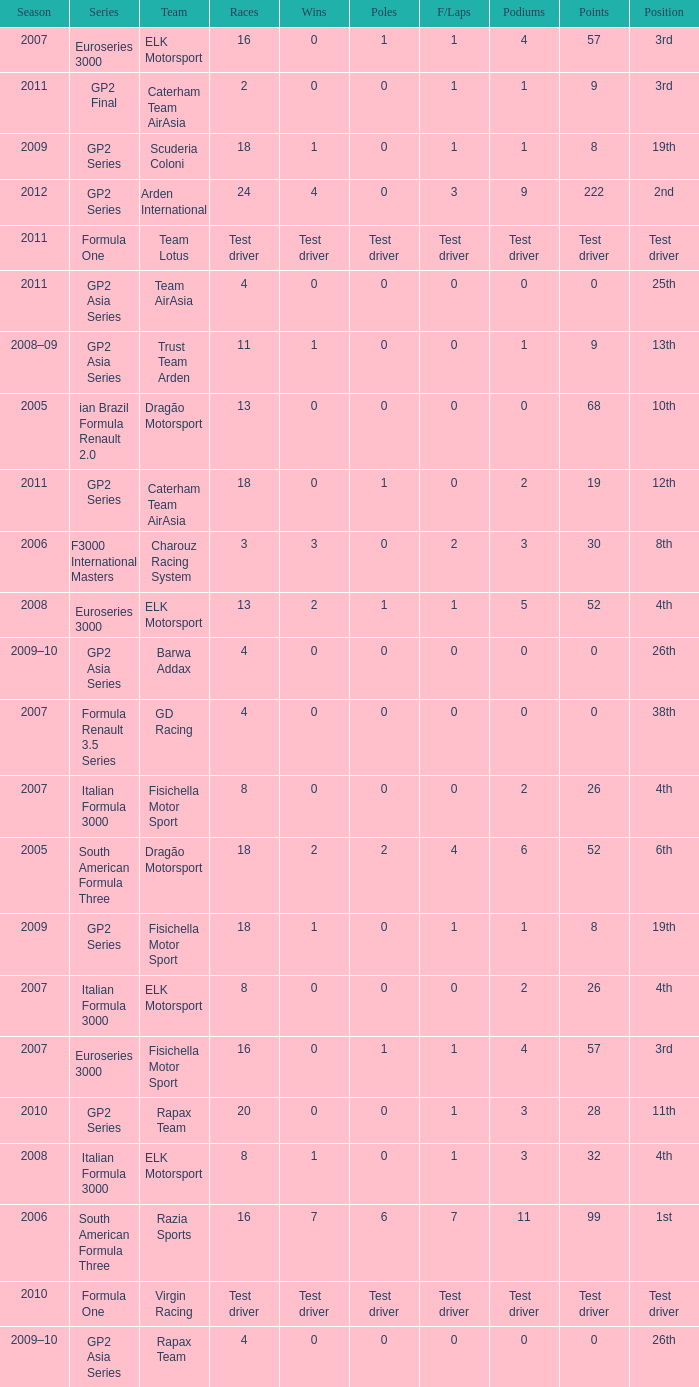How many races did he do in the year he had 8 points? 18, 18. 